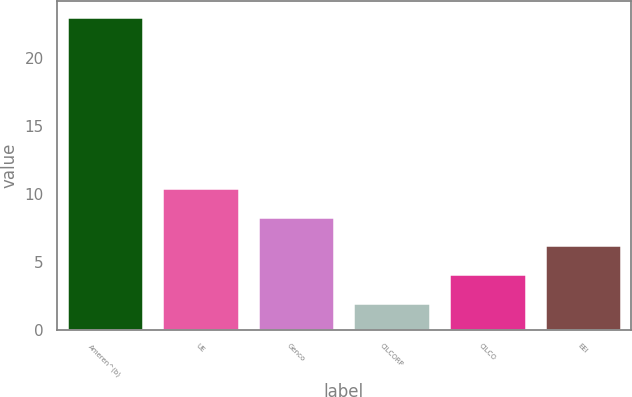<chart> <loc_0><loc_0><loc_500><loc_500><bar_chart><fcel>Ameren^(b)<fcel>UE<fcel>Genco<fcel>CILCORP<fcel>CILCO<fcel>EEI<nl><fcel>23<fcel>10.4<fcel>8.3<fcel>2<fcel>4.1<fcel>6.2<nl></chart> 